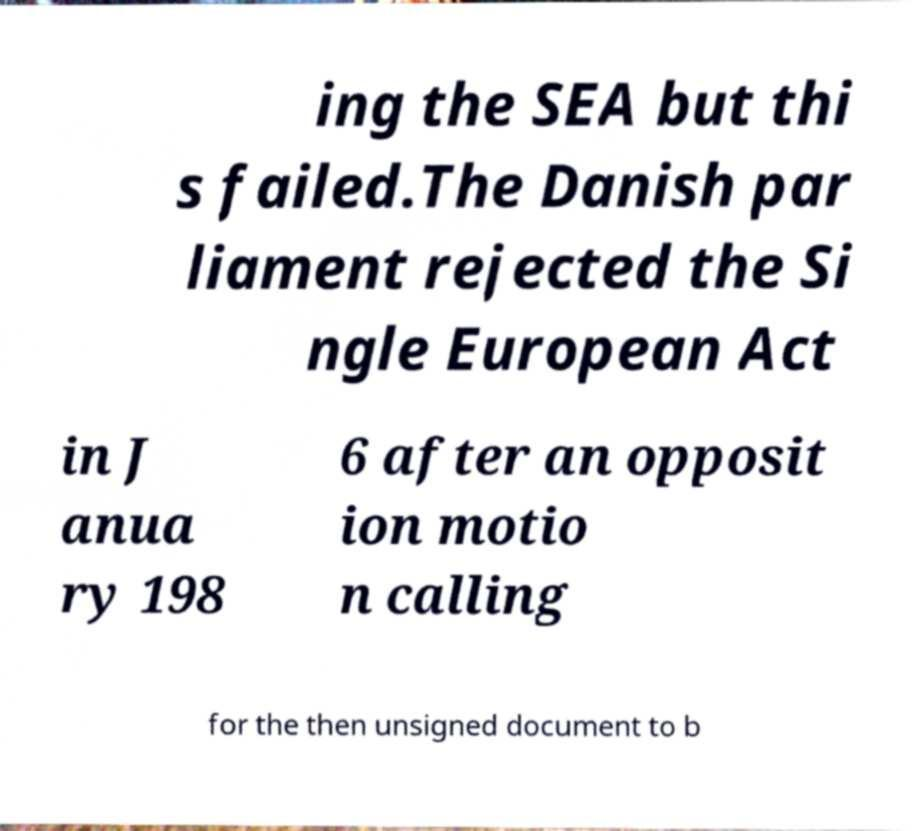I need the written content from this picture converted into text. Can you do that? ing the SEA but thi s failed.The Danish par liament rejected the Si ngle European Act in J anua ry 198 6 after an opposit ion motio n calling for the then unsigned document to b 